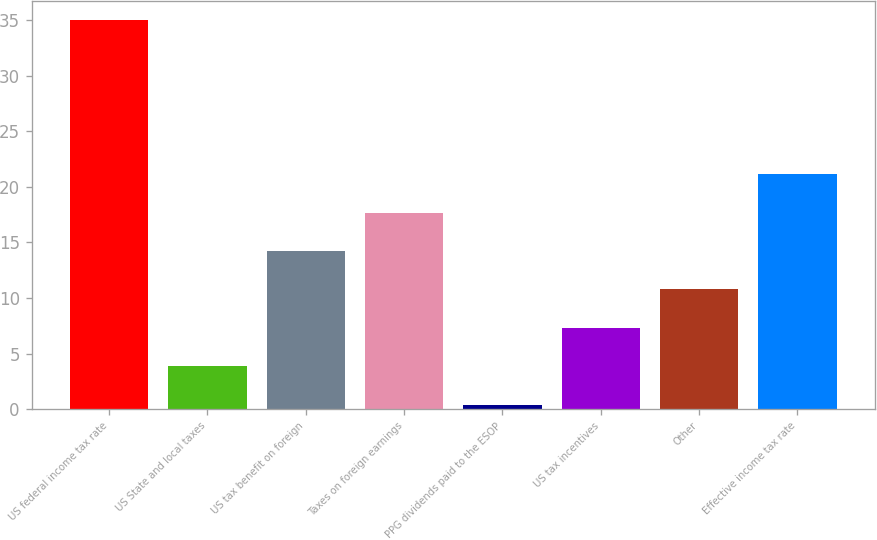Convert chart. <chart><loc_0><loc_0><loc_500><loc_500><bar_chart><fcel>US federal income tax rate<fcel>US State and local taxes<fcel>US tax benefit on foreign<fcel>Taxes on foreign earnings<fcel>PPG dividends paid to the ESOP<fcel>US tax incentives<fcel>Other<fcel>Effective income tax rate<nl><fcel>35<fcel>3.86<fcel>14.24<fcel>17.7<fcel>0.4<fcel>7.32<fcel>10.78<fcel>21.16<nl></chart> 